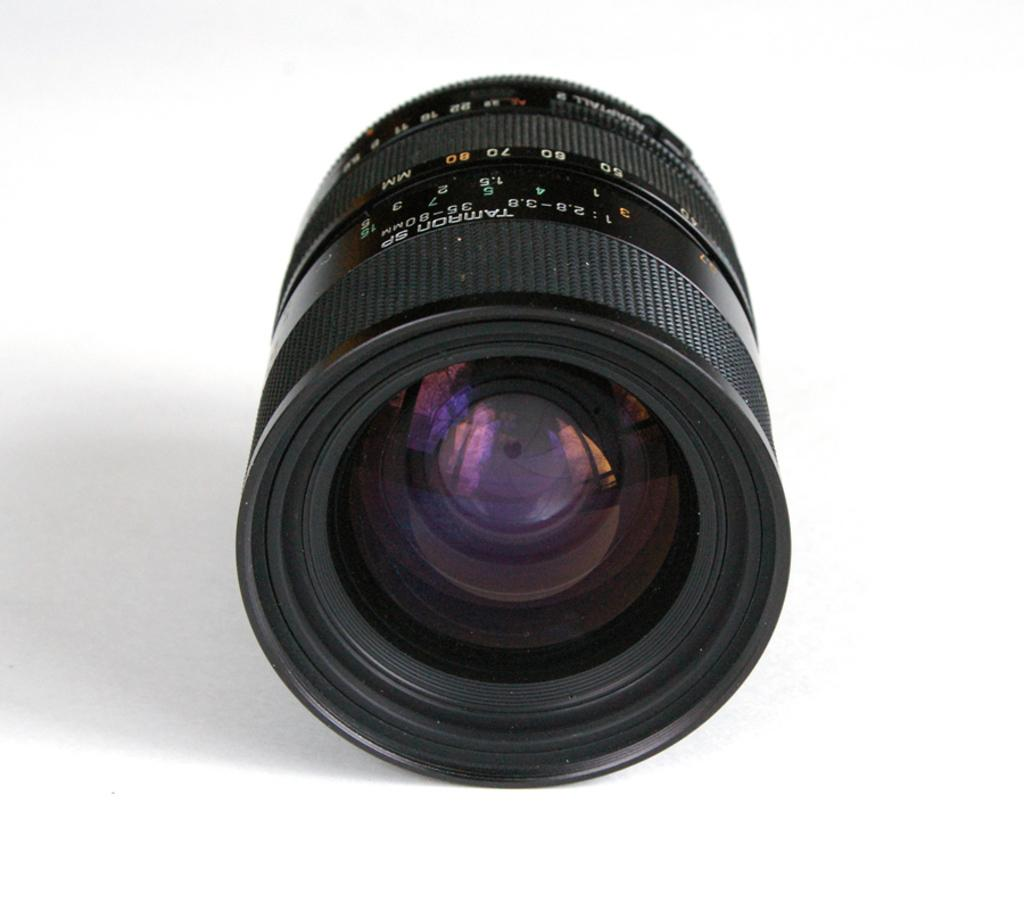What is the main subject of the image? The main subject of the image is the camera lens. What color is the background of the image? The background of the image is white in color. What type of rhythm is being taught in the class visible in the image? There is no class or any indication of rhythm in the image; it only features a camera lens and a white background. 